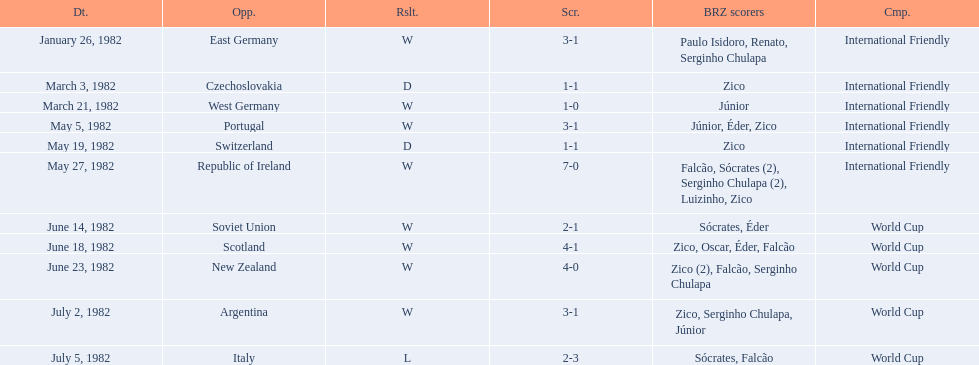What were the scores of each of game in the 1982 brazilian football games? 3-1, 1-1, 1-0, 3-1, 1-1, 7-0, 2-1, 4-1, 4-0, 3-1, 2-3. Of those, which were scores from games against portugal and the soviet union? 3-1, 2-1. And between those two games, against which country did brazil score more goals? Portugal. 